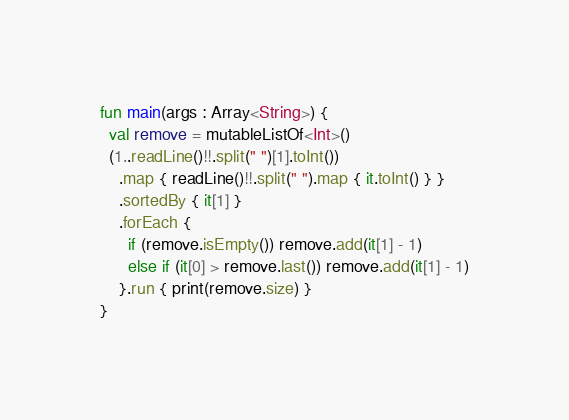Convert code to text. <code><loc_0><loc_0><loc_500><loc_500><_Kotlin_>fun main(args : Array<String>) {
  val remove = mutableListOf<Int>()
  (1..readLine()!!.split(" ")[1].toInt())
    .map { readLine()!!.split(" ").map { it.toInt() } }
    .sortedBy { it[1] }
    .forEach { 
      if (remove.isEmpty()) remove.add(it[1] - 1)
      else if (it[0] > remove.last()) remove.add(it[1] - 1)
    }.run { print(remove.size) }
}</code> 